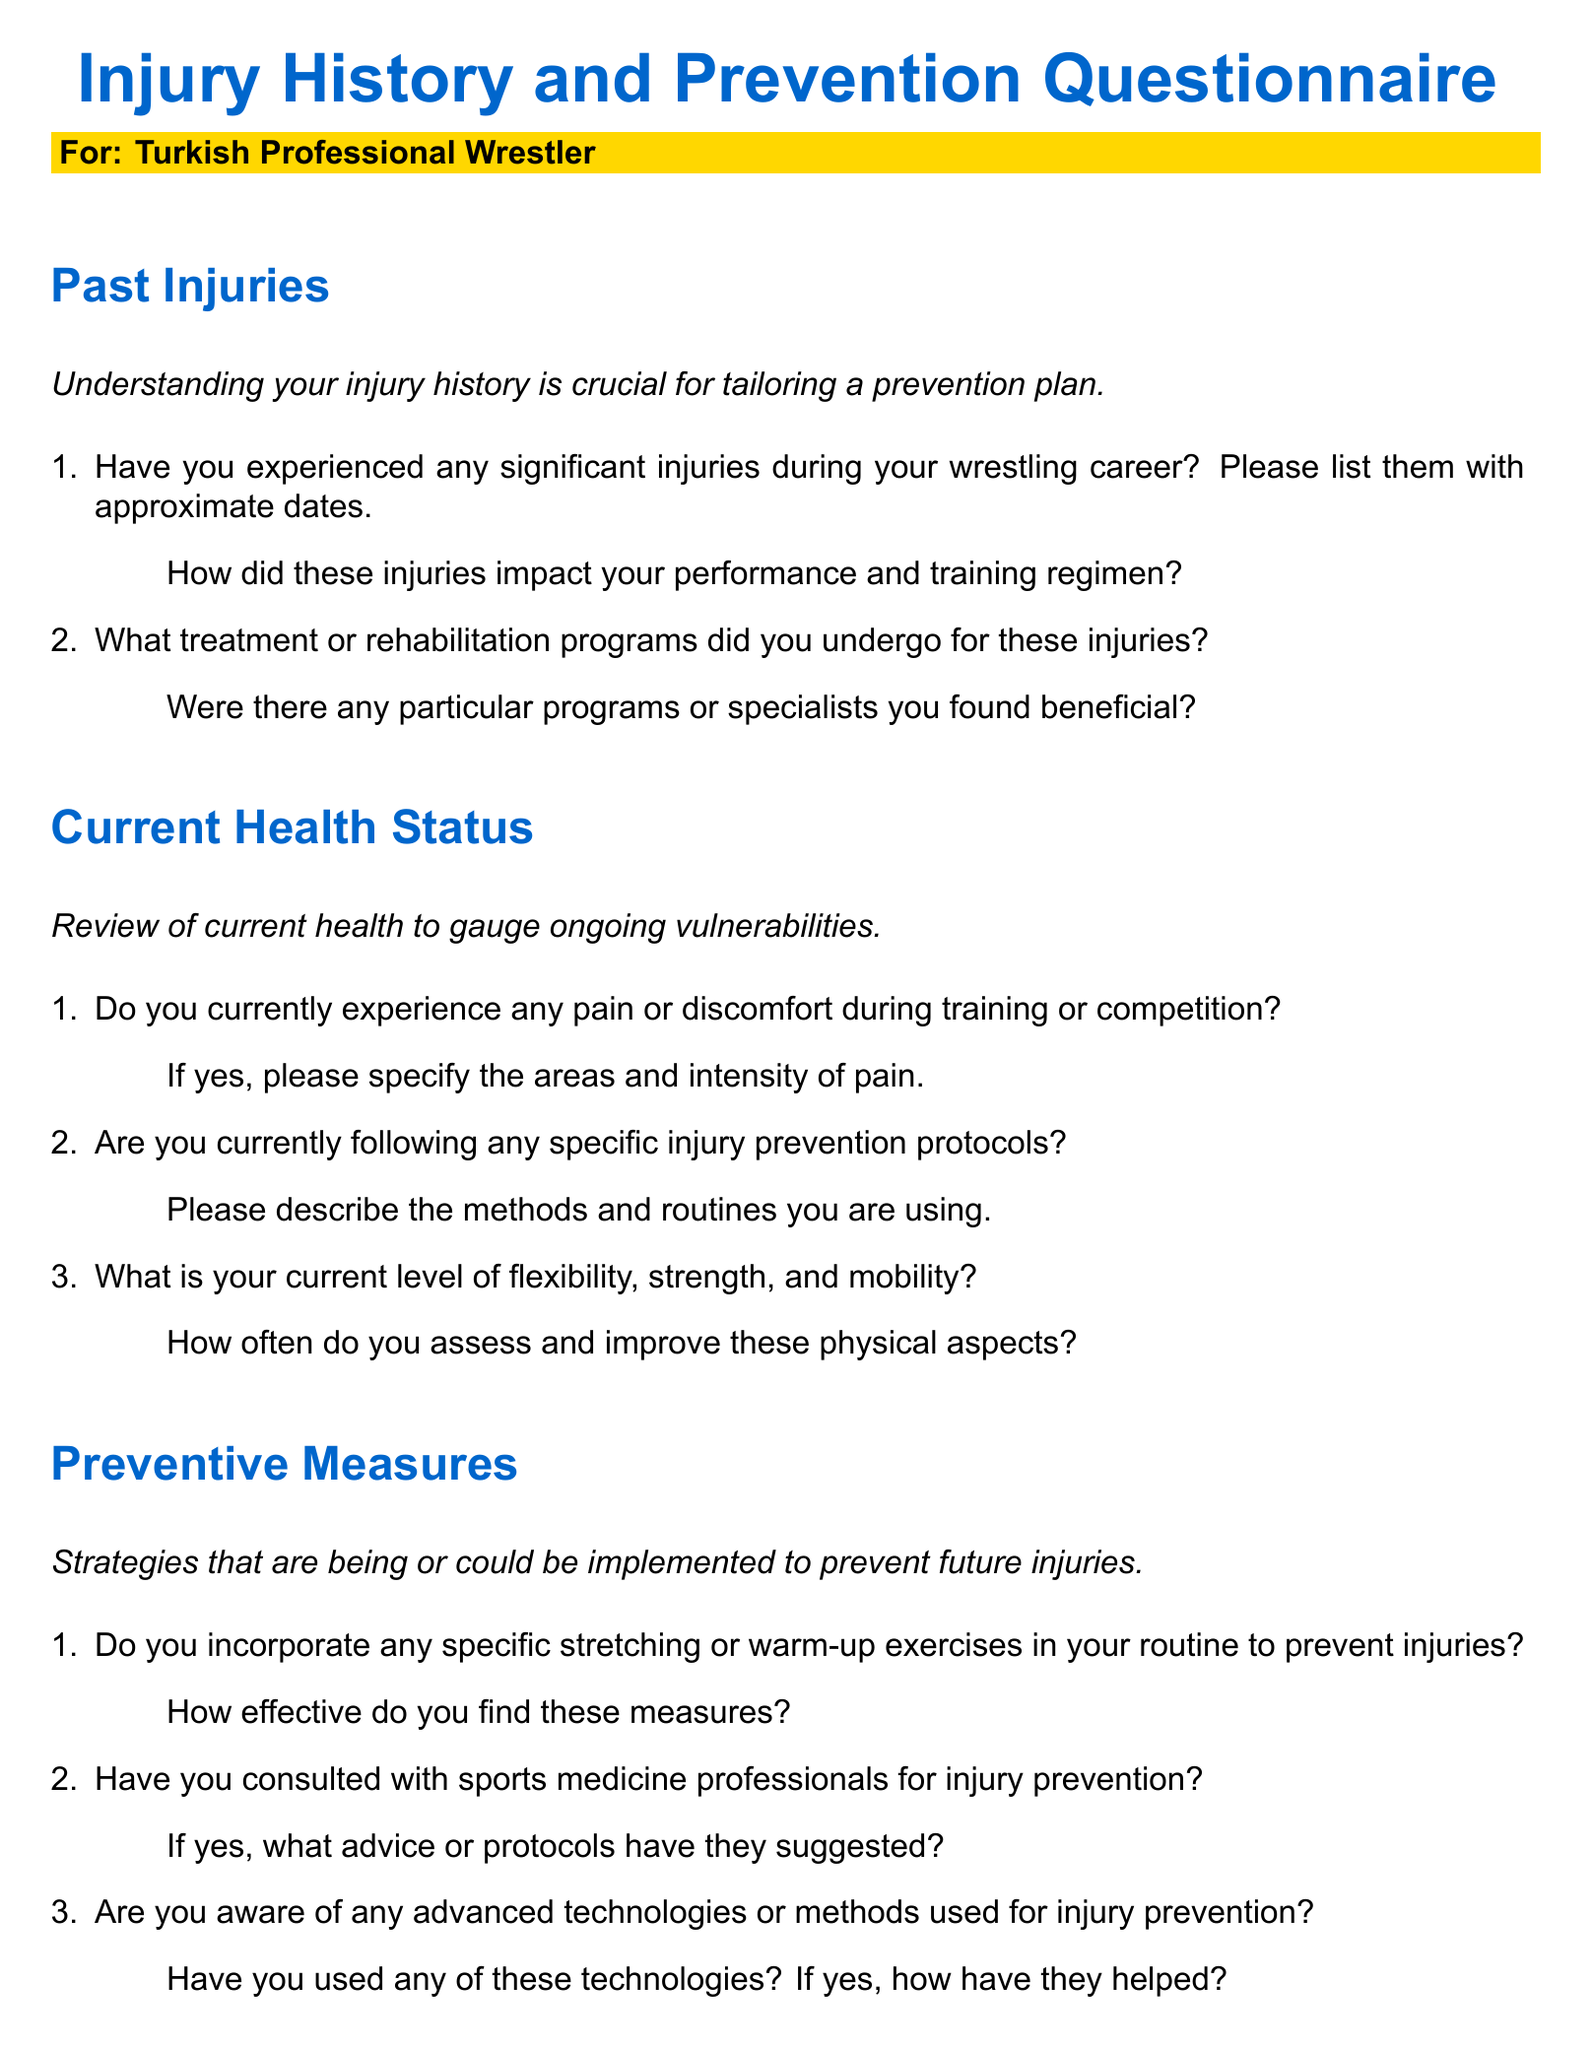What is the title of the questionnaire? The title is provided at the top of the document and specifies the focus of the questionnaire.
Answer: Injury History and Prevention Questionnaire Who is the intended audience for the questionnaire? The intended audience is clearly labeled in a colored box underneath the title.
Answer: Turkish Professional Wrestler How many sections are there in the questionnaire? The document contains distinct sections that are explicitly titled throughout.
Answer: Four What is the first question regarding past injuries? The first question is related to the experience of significant injuries and is crucial for understanding injury history.
Answer: Have you experienced any significant injuries during your wrestling career? Please list them with approximate dates What type of professionals does the questionnaire suggest consulting for injury prevention? The questionnaire mentions a specific category of professionals who can provide guidance.
Answer: Sports medicine professionals What aspect of current health does the second question in the Current Health Status section address? The second question focuses on a specific ongoing health issue among wrestlers.
Answer: Pain or discomfort during training or competition What recovery techniques does the questionnaire ask about in relation to future injury prevention? The questionnaire seeks information on various methods that can promote recovery and prevent injuries.
Answer: Effective recovery techniques What does the last question in the Future Risks and Recommendations section inquire about? The last question prompts the respondent to reflect on any lifestyle changes relevant to injury prevention.
Answer: Are there any lifestyle changes you plan to implement to enhance your injury prevention strategy? 